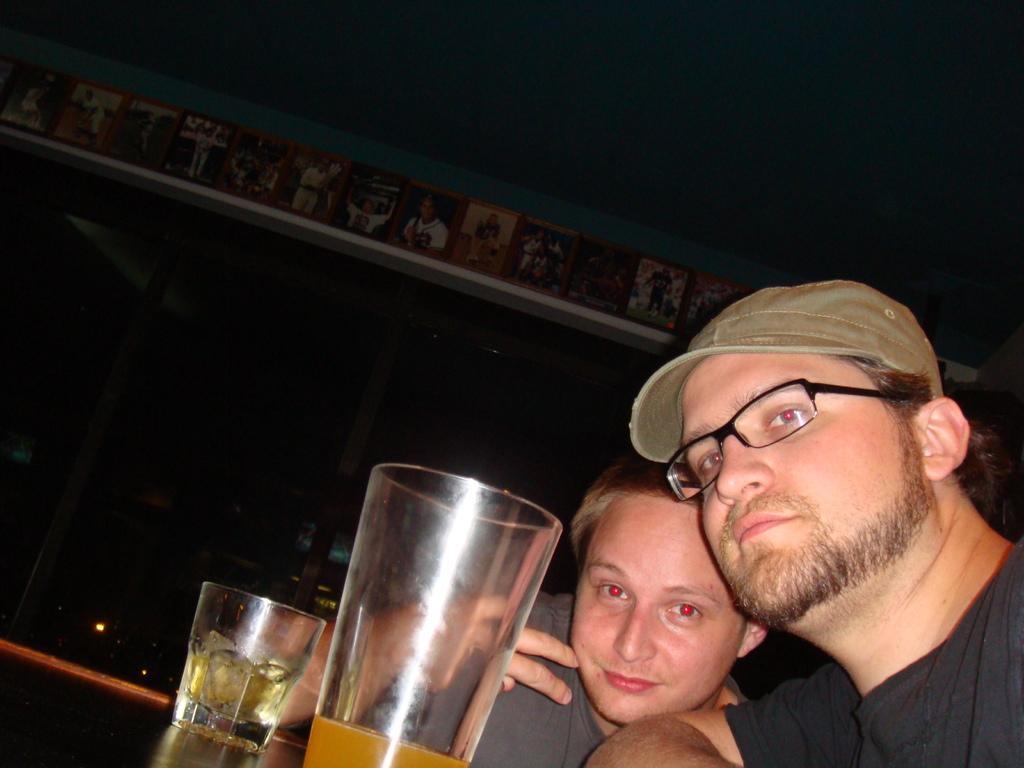In one or two sentences, can you explain what this image depicts? In this image we can see two persons wearing black and grey color T-shirt person wearing black color T-shirt also wearing spectacles and cap and there are some glasses in which there is drink and in the background of the image there are some pictures attached to the wall. 